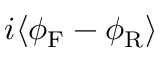Convert formula to latex. <formula><loc_0><loc_0><loc_500><loc_500>i \langle \phi _ { F } - \phi _ { R } \rangle</formula> 